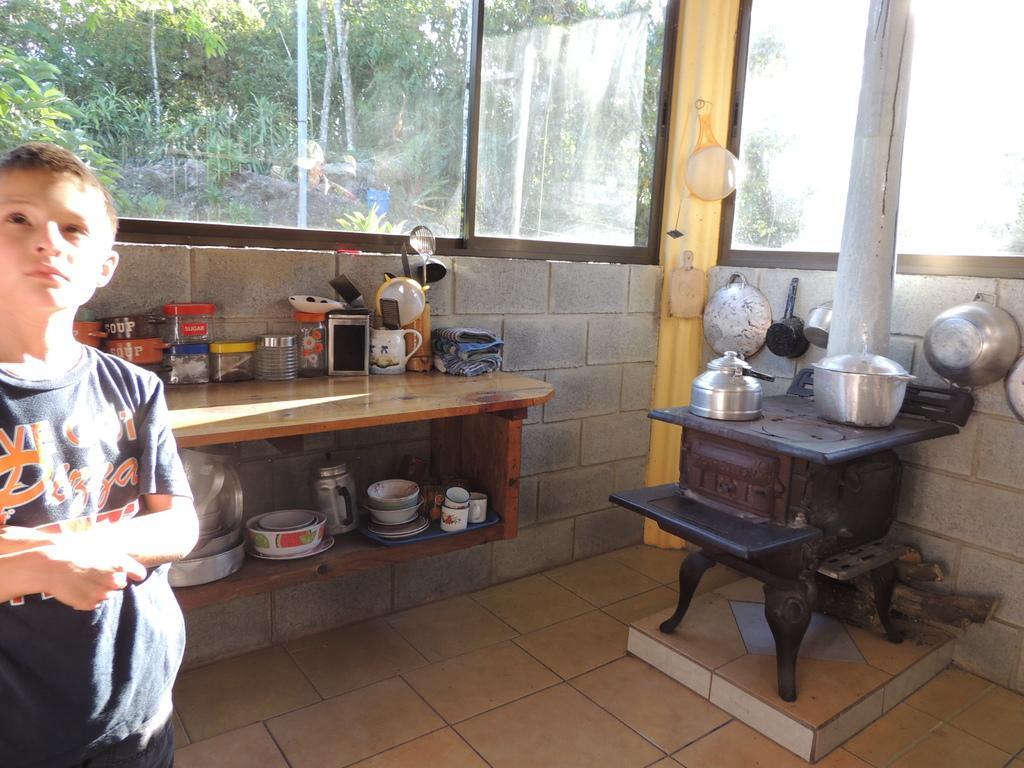Please provide a concise description of this image. Through window glass we can see trees. Here on a platform we can see mug, containers. Here we can see dishes over a wall. This is a strainer. Here we can see one boy standing on the floor. 